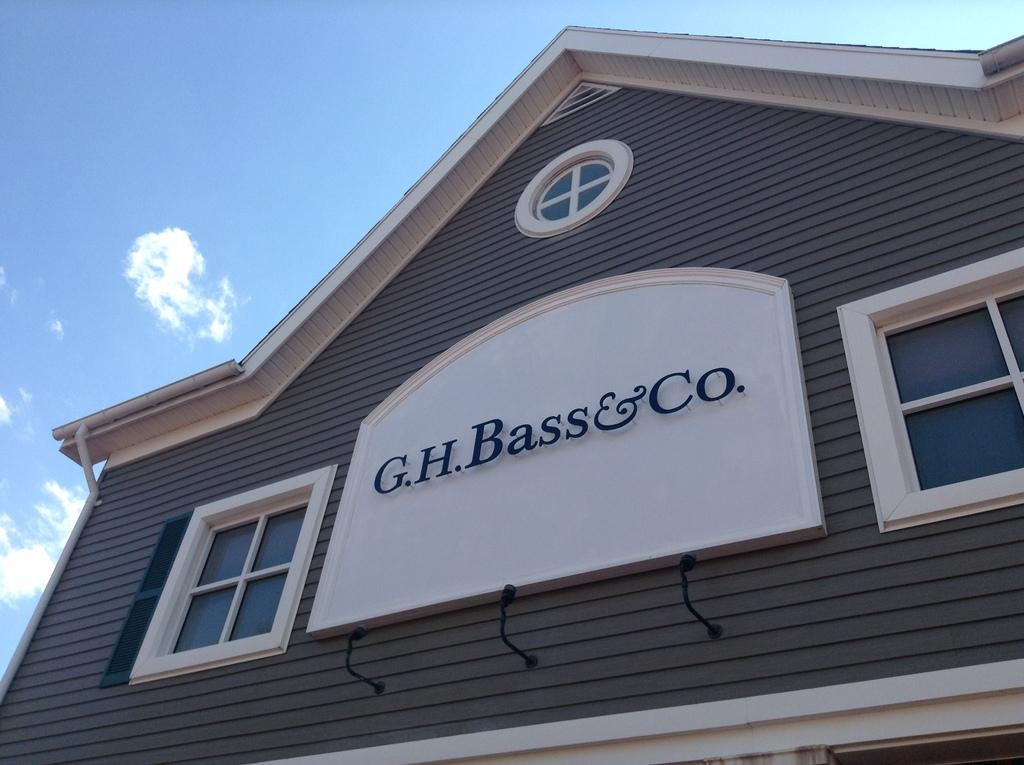What is the main subject of the picture? The main subject of the picture is a house. How many windows are on the house? The house has two windows. What is written on the windows? The windows have the name "G. H. Bass and Co" on them. What can be seen in the background of the picture? There is a sky visible in the background of the picture. What is the condition of the sky in the picture? Clouds are present in the sky. Who is the owner of the quarter in the image? There is no quarter present in the image, so it is not possible to determine the owner. What type of shake is being prepared in the image? There is no shake or any indication of food preparation in the image; it features a house with windows and a sky in the background. 